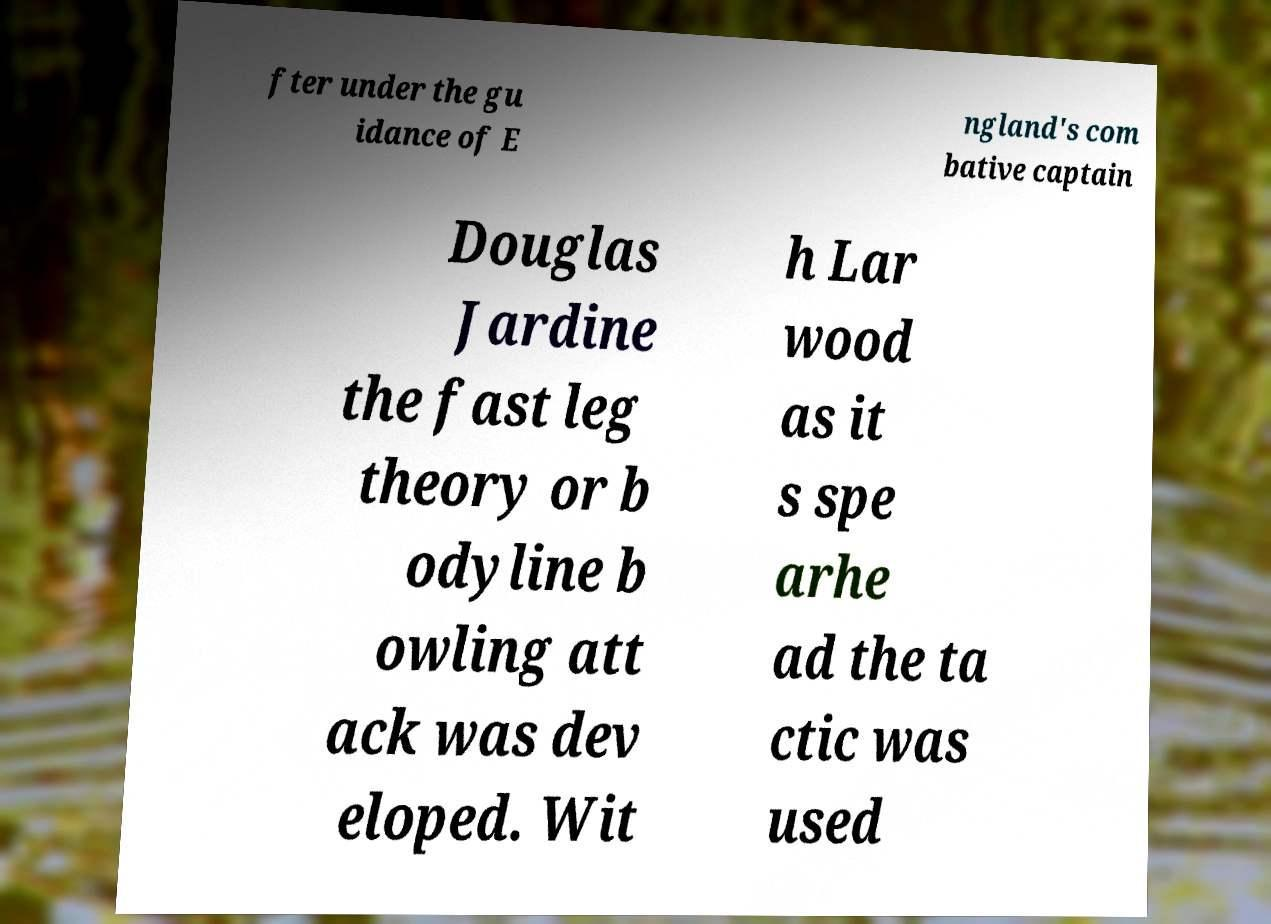Could you assist in decoding the text presented in this image and type it out clearly? fter under the gu idance of E ngland's com bative captain Douglas Jardine the fast leg theory or b odyline b owling att ack was dev eloped. Wit h Lar wood as it s spe arhe ad the ta ctic was used 